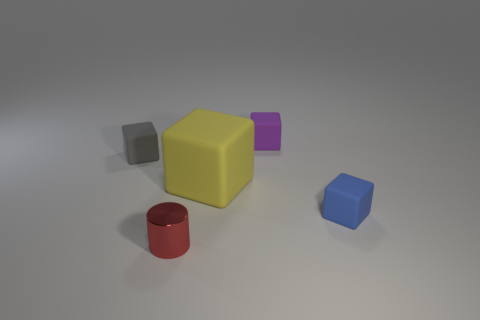Subtract 1 blocks. How many blocks are left? 3 Add 2 large yellow rubber objects. How many objects exist? 7 Subtract all cylinders. How many objects are left? 4 Add 1 small red cubes. How many small red cubes exist? 1 Subtract 0 gray spheres. How many objects are left? 5 Subtract all tiny metal things. Subtract all tiny gray rubber cubes. How many objects are left? 3 Add 1 large objects. How many large objects are left? 2 